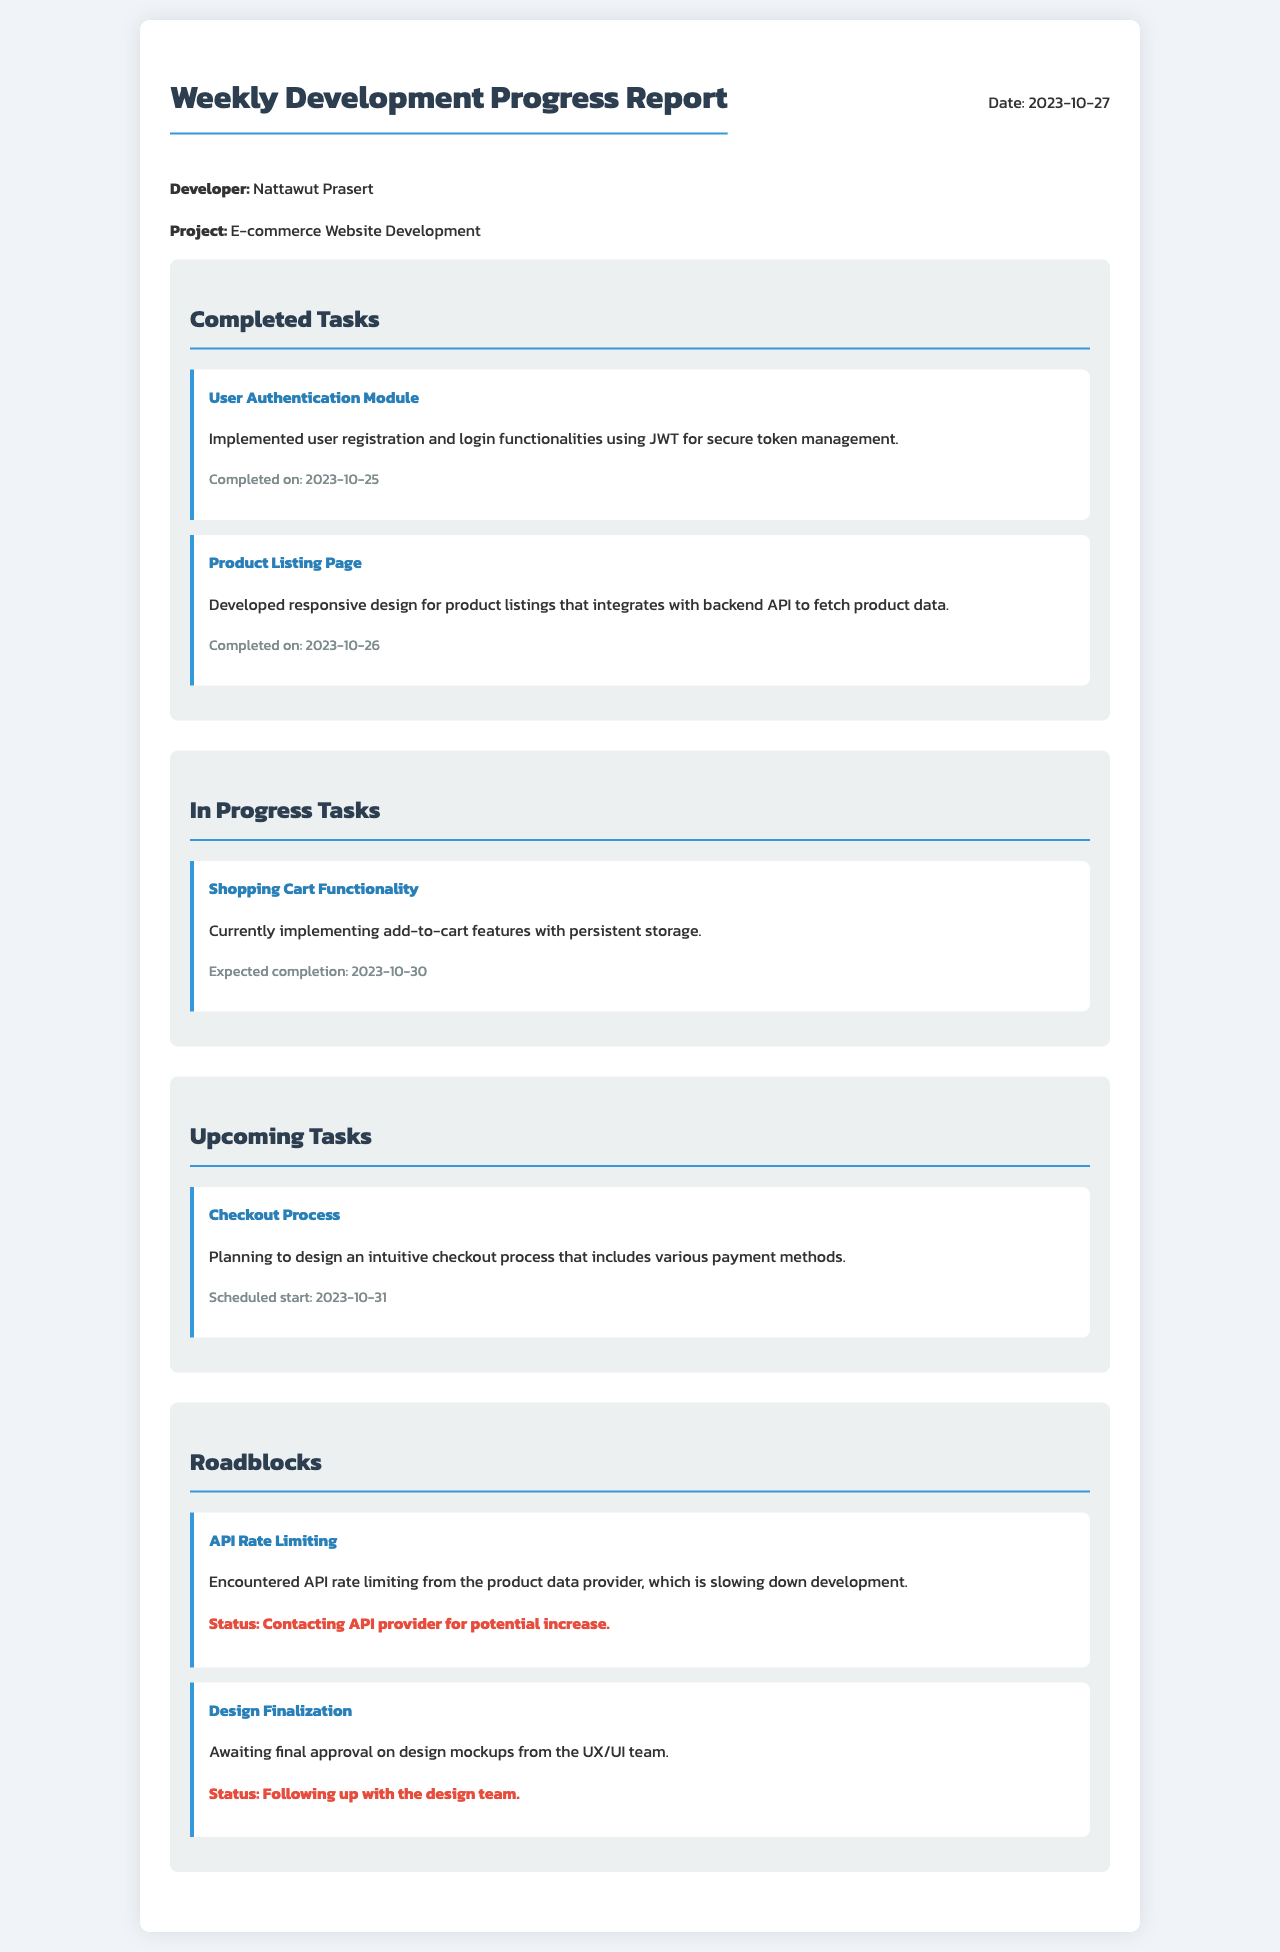What is the name of the developer? The developer's name is stated explicitly at the beginning of the report, which is Nattawut Prasert.
Answer: Nattawut Prasert What is the project title? The project title is provided right under the developer's name in the report, which is E-commerce Website Development.
Answer: E-commerce Website Development When was the User Authentication Module completed? The completion date for the User Authentication Module is listed below the task description, which is 2023-10-25.
Answer: 2023-10-25 What feature is currently being implemented? The document specifies that the task currently in progress is the Shopping Cart Functionality.
Answer: Shopping Cart Functionality What is the expected completion date for the Shopping Cart Functionality? The expected completion date is provided within the task description for the Shopping Cart Functionality, which is 2023-10-30.
Answer: 2023-10-30 What is the first upcoming task? The first upcoming task listed in the report is the Checkout Process.
Answer: Checkout Process What issue is being encountered related to API? The document mentions an issue with API Rate Limiting that is affecting development.
Answer: API Rate Limiting What is the status for the issue regarding API Rate Limiting? The status for the API Rate Limiting issue is stated to be contacting the API provider for potential increase.
Answer: Contacting API provider for potential increase How many completed tasks are listed in the report? The report includes a count of completed tasks; there are two completed tasks mentioned.
Answer: 2 